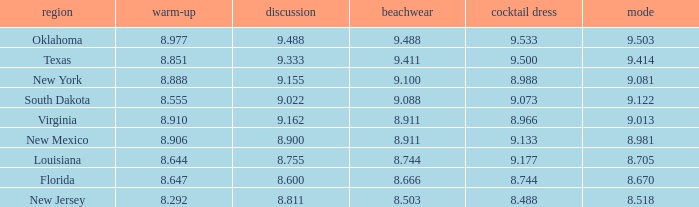 what's the evening gown where preliminaries is 8.977 9.533. 